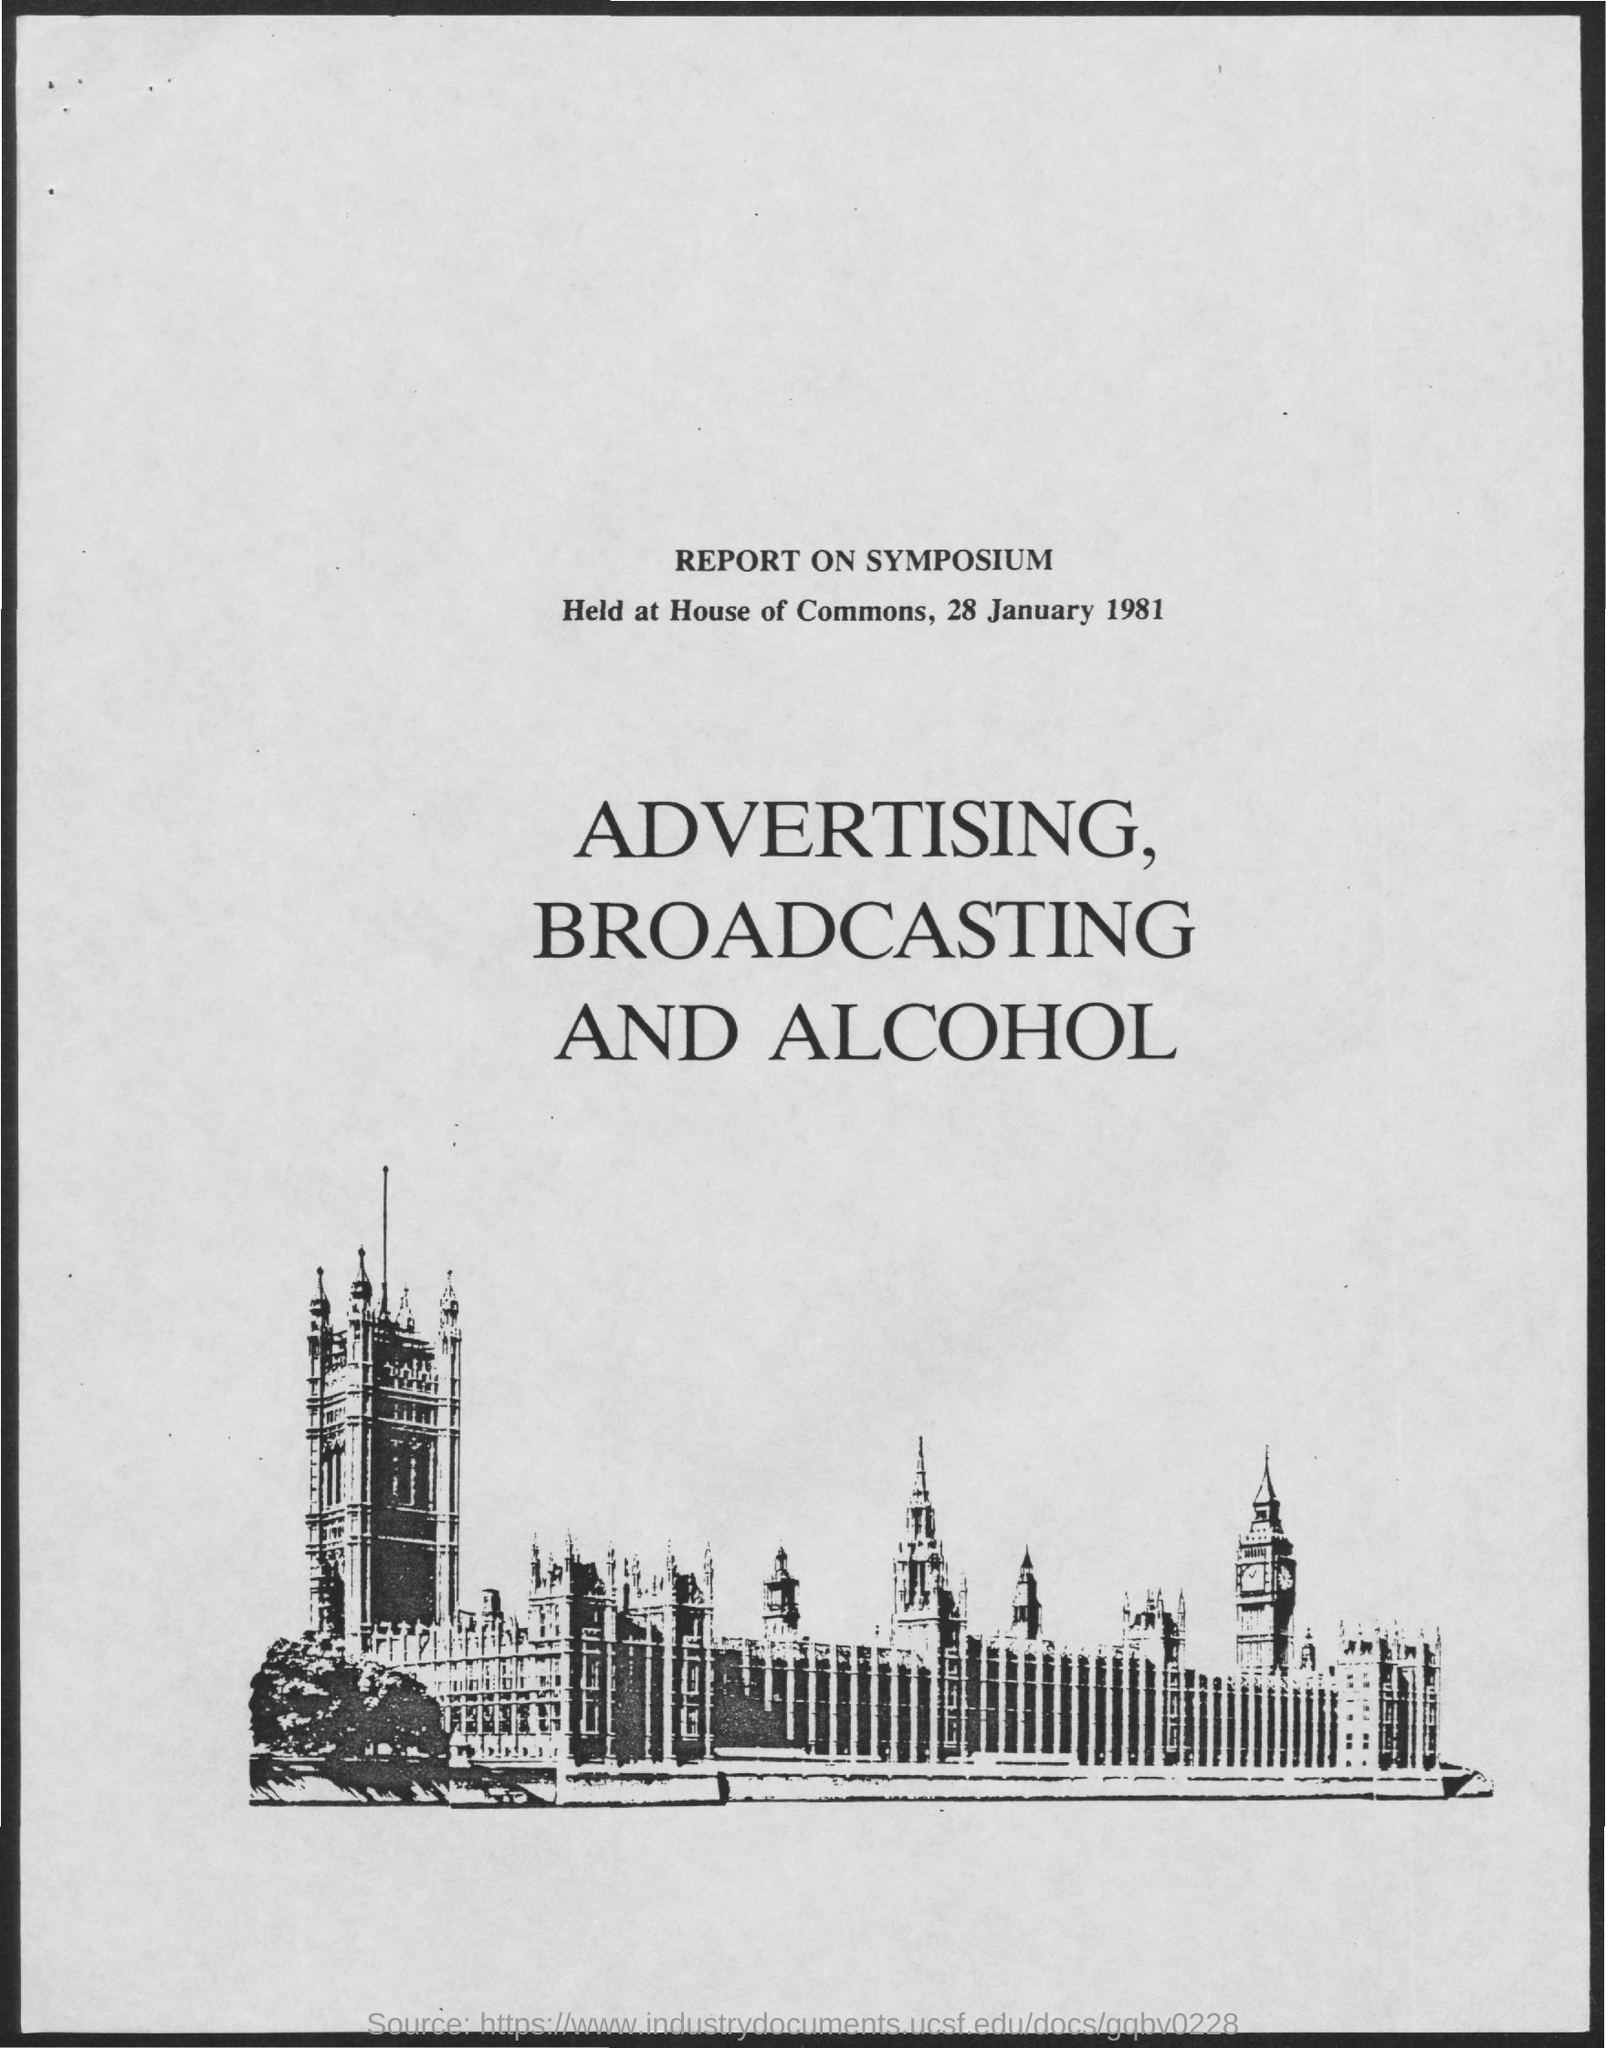What is the report on?
Keep it short and to the point. Report on symposium. Where was the Symposium held?
Give a very brief answer. House of Commons. When was the Symposium held?
Keep it short and to the point. 28 January 1981. What is the topic?
Keep it short and to the point. Advertising, broadcasting and alcohol. 